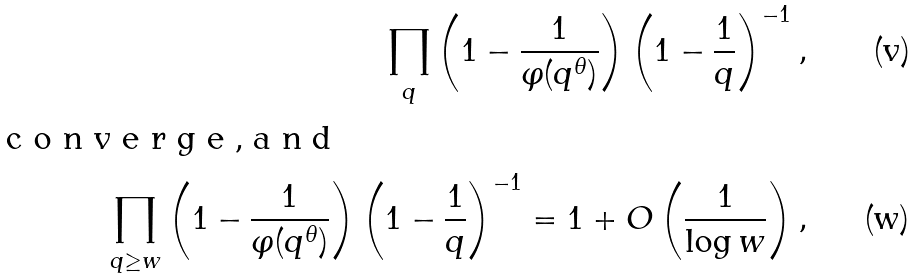Convert formula to latex. <formula><loc_0><loc_0><loc_500><loc_500>\prod _ { q } \left ( 1 - \frac { 1 } { \varphi ( q ^ { \theta } ) } \right ) \left ( 1 - \frac { 1 } { q } \right ) ^ { - 1 } , \\ \intertext { c o n v e r g e , a n d } \prod _ { q \geq w } \left ( 1 - \frac { 1 } { \varphi ( q ^ { \theta } ) } \right ) \left ( 1 - \frac { 1 } { q } \right ) ^ { - 1 } = 1 + O \left ( \frac { 1 } { \log w } \right ) ,</formula> 